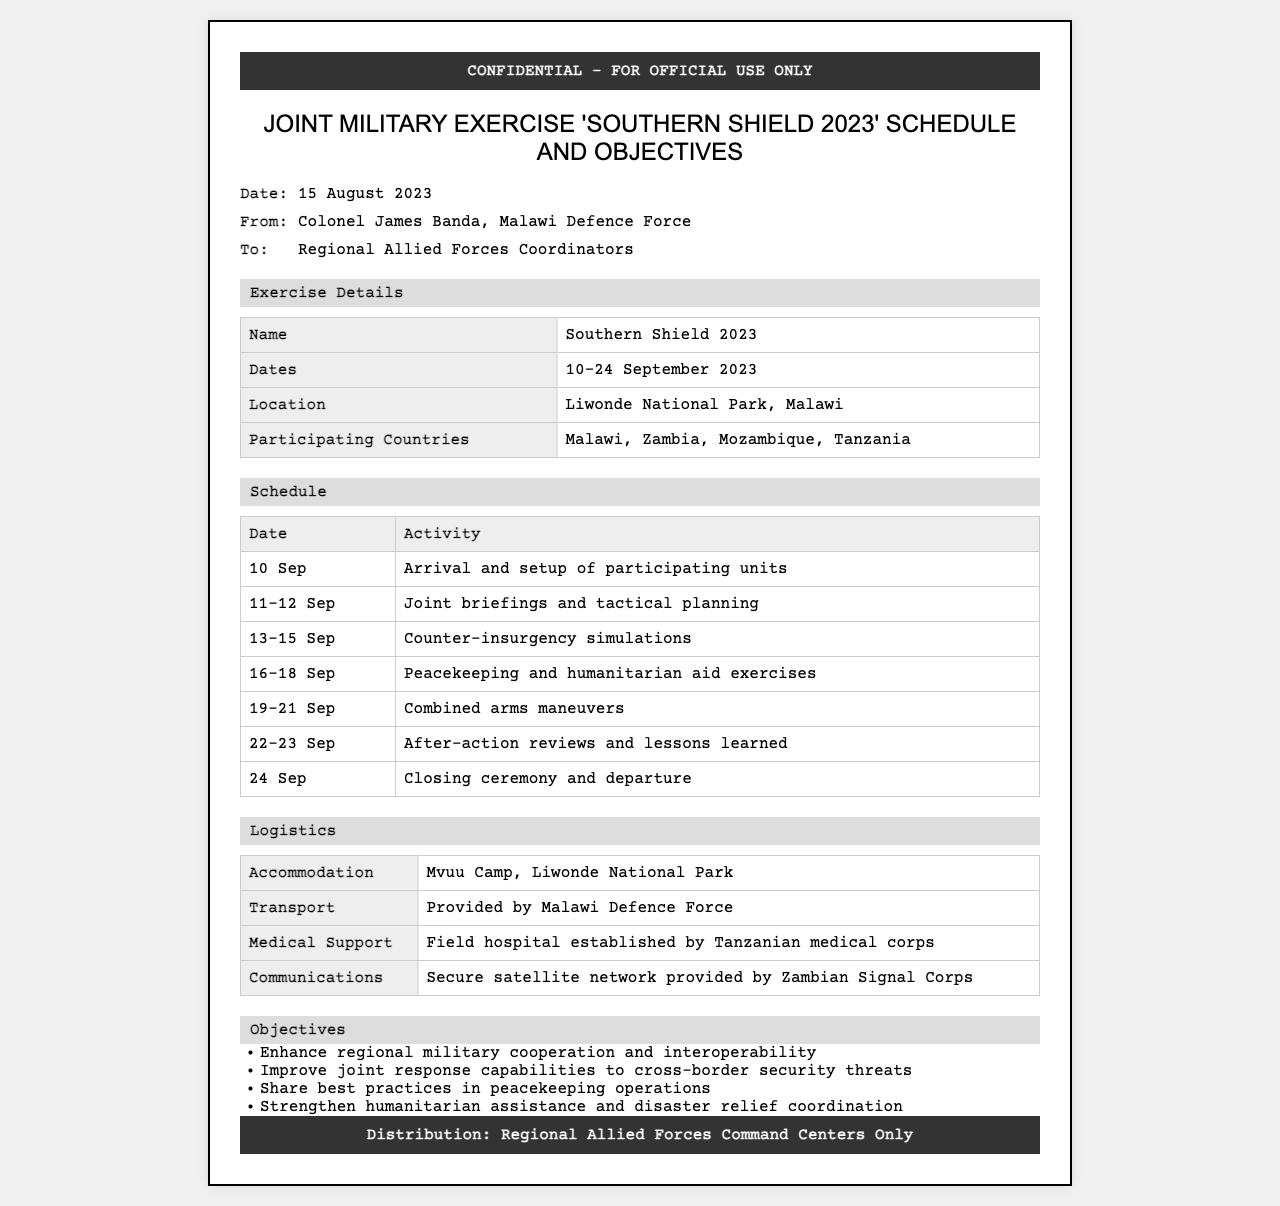What is the name of the exercise? The name of the exercise is mentioned in the header section as "Southern Shield 2023".
Answer: Southern Shield 2023 Who is the sender of the document? The sender is identified in the meta-info section, where it states "Colonel James Banda, Malawi Defence Force".
Answer: Colonel James Banda, Malawi Defence Force What are the dates for the exercise? The document specifies the dates for the exercise in the details section, indicating "10-24 September 2023".
Answer: 10-24 September 2023 Where will the exercise take place? The location is clearly stated in the details section as "Liwonde National Park, Malawi".
Answer: Liwonde National Park, Malawi What logistically supports medical needs during the exercise? The logistics section mentions that "Field hospital established by Tanzanian medical corps" will provide medical support.
Answer: Field hospital established by Tanzanian medical corps What is one of the objectives of the exercise? One of the objectives can be found in the objectives section, listed as "Enhance regional military cooperation and interoperability".
Answer: Enhance regional military cooperation and interoperability How many participating countries are involved in the exercise? The document lists the participating countries as "Malawi, Zambia, Mozambique, Tanzania". The count is four.
Answer: Four What is the date for the closing ceremony? The schedule section lists the closing ceremony date as "24 Sep".
Answer: 24 Sep What type of communication network will be used? The logistics section mentions "Secure satellite network provided by Zambian Signal Corps" for communications.
Answer: Secure satellite network provided by Zambian Signal Corps 